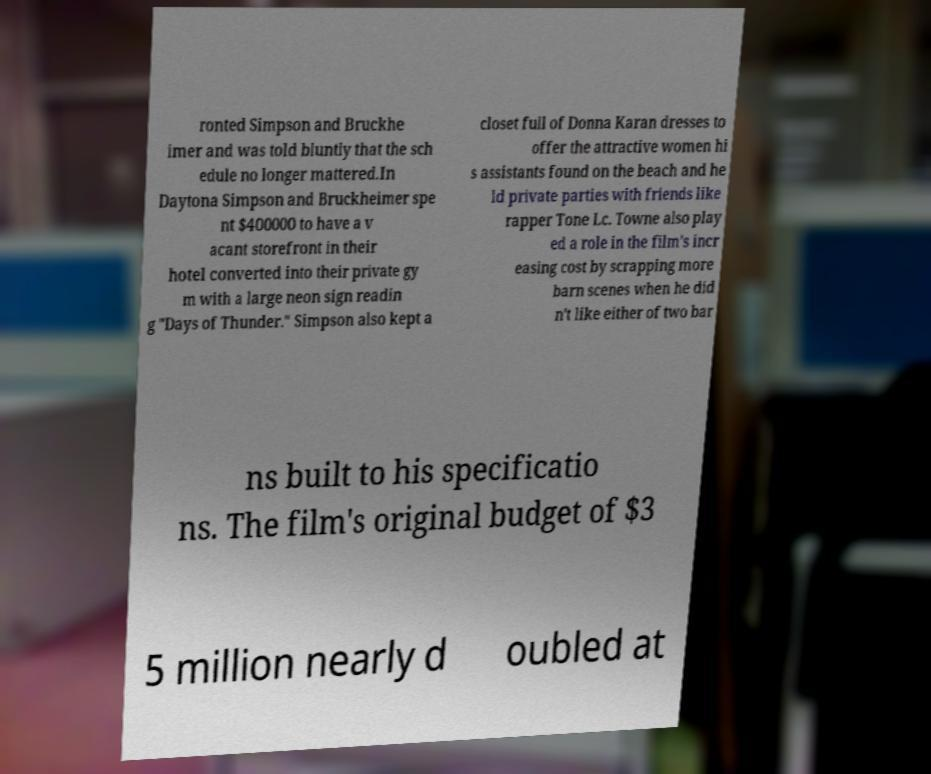Could you extract and type out the text from this image? ronted Simpson and Bruckhe imer and was told bluntly that the sch edule no longer mattered.In Daytona Simpson and Bruckheimer spe nt $400000 to have a v acant storefront in their hotel converted into their private gy m with a large neon sign readin g "Days of Thunder." Simpson also kept a closet full of Donna Karan dresses to offer the attractive women hi s assistants found on the beach and he ld private parties with friends like rapper Tone Lc. Towne also play ed a role in the film's incr easing cost by scrapping more barn scenes when he did n't like either of two bar ns built to his specificatio ns. The film's original budget of $3 5 million nearly d oubled at 